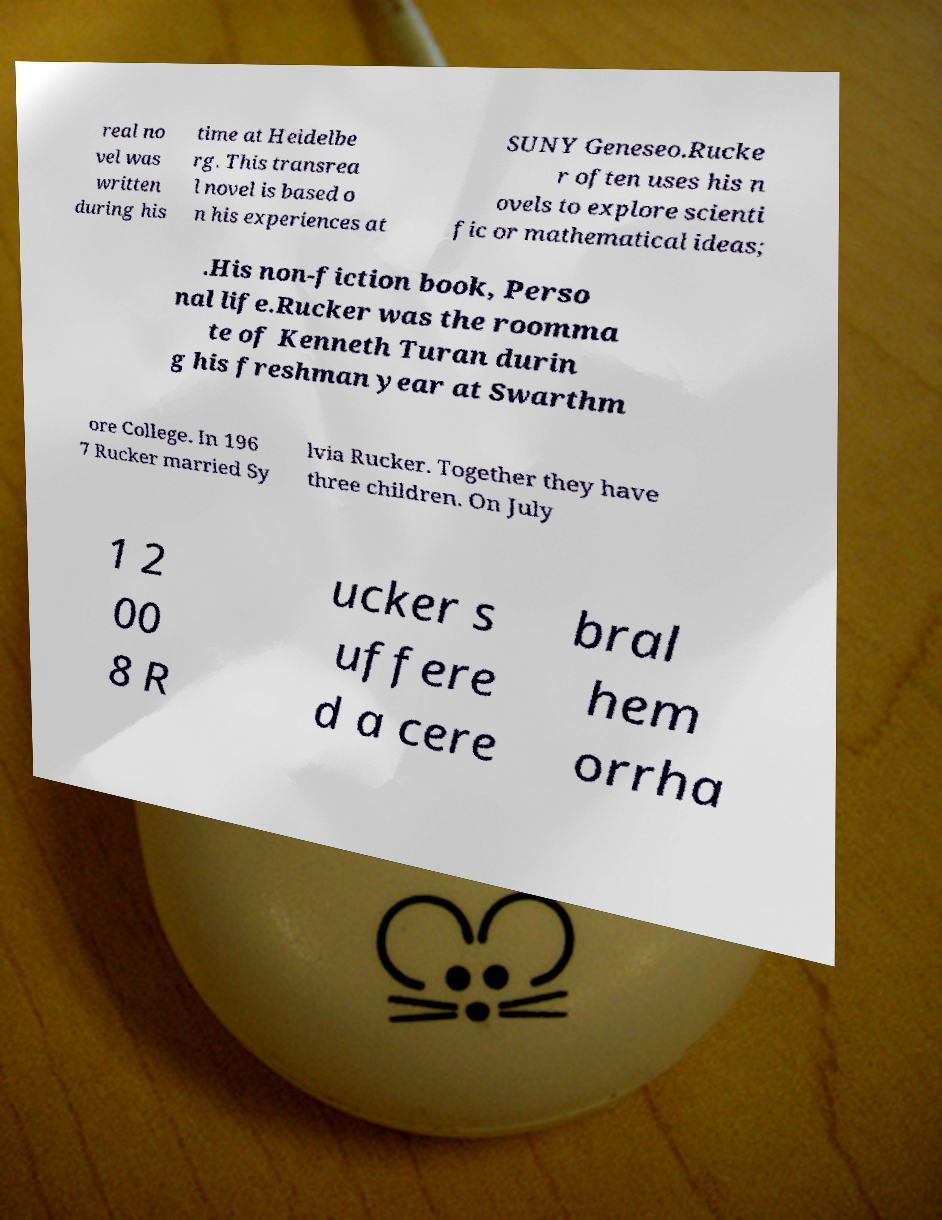Could you assist in decoding the text presented in this image and type it out clearly? real no vel was written during his time at Heidelbe rg. This transrea l novel is based o n his experiences at SUNY Geneseo.Rucke r often uses his n ovels to explore scienti fic or mathematical ideas; .His non-fiction book, Perso nal life.Rucker was the roomma te of Kenneth Turan durin g his freshman year at Swarthm ore College. In 196 7 Rucker married Sy lvia Rucker. Together they have three children. On July 1 2 00 8 R ucker s uffere d a cere bral hem orrha 